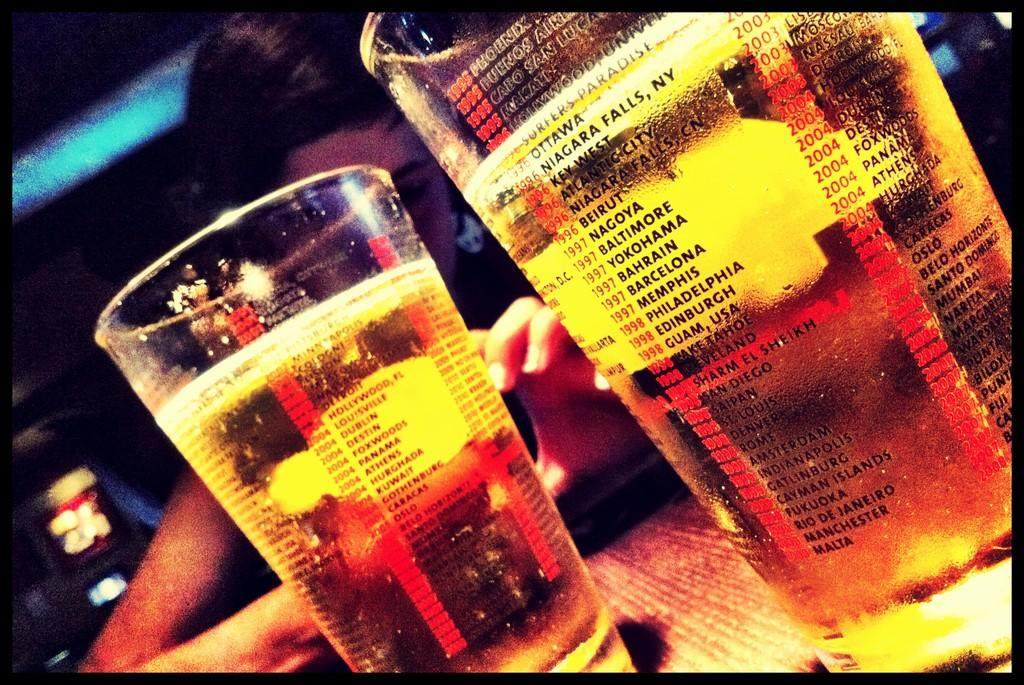<image>
Render a clear and concise summary of the photo. Two glasses of beer with the various dates and locations starting 1995 and ending 2008 screenprinted on the glass. 